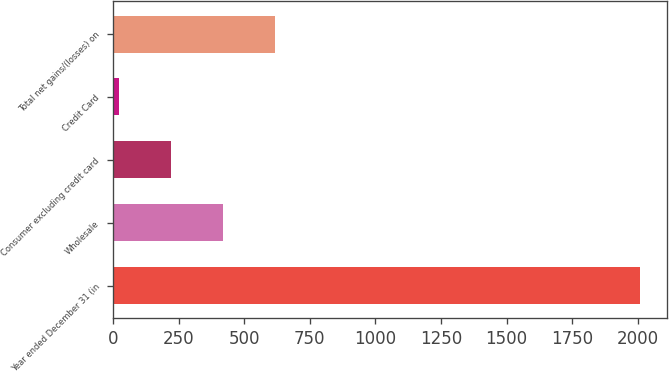<chart> <loc_0><loc_0><loc_500><loc_500><bar_chart><fcel>Year ended December 31 (in<fcel>Wholesale<fcel>Consumer excluding credit card<fcel>Credit Card<fcel>Total net gains/(losses) on<nl><fcel>2009<fcel>418.6<fcel>219.8<fcel>21<fcel>617.4<nl></chart> 